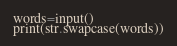<code> <loc_0><loc_0><loc_500><loc_500><_Python_>words=input()
print(str.swapcase(words))
</code> 